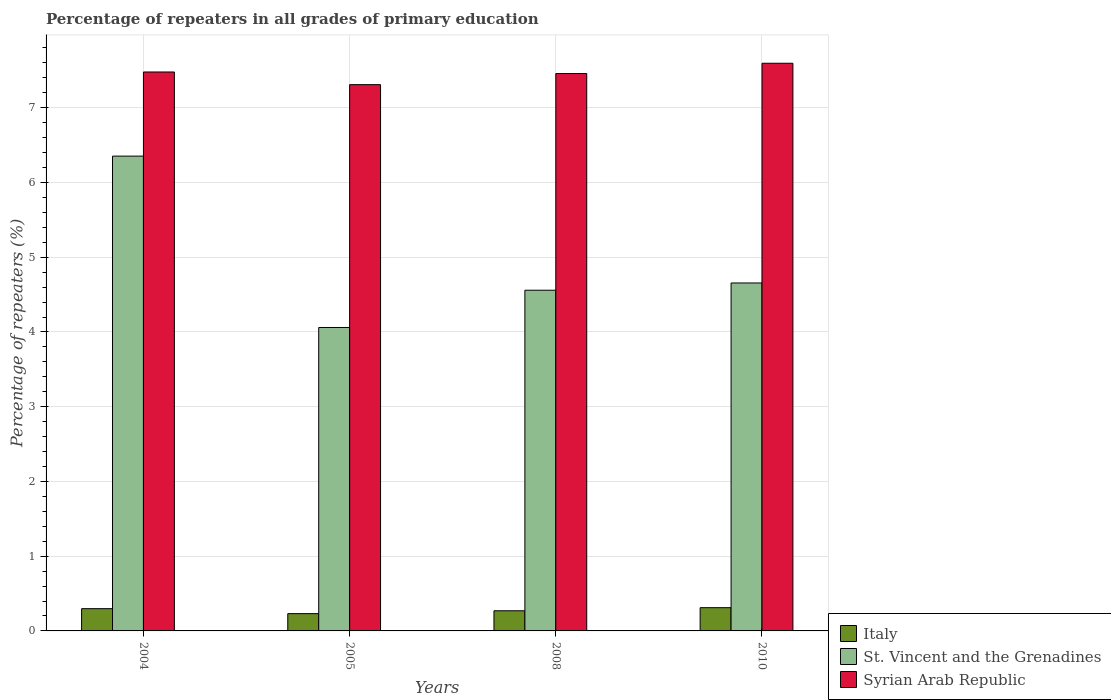How many groups of bars are there?
Offer a terse response. 4. Are the number of bars per tick equal to the number of legend labels?
Offer a terse response. Yes. Are the number of bars on each tick of the X-axis equal?
Your answer should be very brief. Yes. How many bars are there on the 2nd tick from the right?
Ensure brevity in your answer.  3. What is the label of the 3rd group of bars from the left?
Your answer should be compact. 2008. In how many cases, is the number of bars for a given year not equal to the number of legend labels?
Make the answer very short. 0. What is the percentage of repeaters in Italy in 2005?
Provide a succinct answer. 0.23. Across all years, what is the maximum percentage of repeaters in Italy?
Ensure brevity in your answer.  0.31. Across all years, what is the minimum percentage of repeaters in St. Vincent and the Grenadines?
Give a very brief answer. 4.06. What is the total percentage of repeaters in St. Vincent and the Grenadines in the graph?
Offer a very short reply. 19.63. What is the difference between the percentage of repeaters in Syrian Arab Republic in 2008 and that in 2010?
Your answer should be compact. -0.14. What is the difference between the percentage of repeaters in Italy in 2008 and the percentage of repeaters in St. Vincent and the Grenadines in 2004?
Offer a very short reply. -6.08. What is the average percentage of repeaters in Italy per year?
Offer a very short reply. 0.28. In the year 2010, what is the difference between the percentage of repeaters in Syrian Arab Republic and percentage of repeaters in St. Vincent and the Grenadines?
Give a very brief answer. 2.94. In how many years, is the percentage of repeaters in Syrian Arab Republic greater than 0.6000000000000001 %?
Ensure brevity in your answer.  4. What is the ratio of the percentage of repeaters in St. Vincent and the Grenadines in 2005 to that in 2008?
Offer a very short reply. 0.89. Is the difference between the percentage of repeaters in Syrian Arab Republic in 2004 and 2008 greater than the difference between the percentage of repeaters in St. Vincent and the Grenadines in 2004 and 2008?
Make the answer very short. No. What is the difference between the highest and the second highest percentage of repeaters in St. Vincent and the Grenadines?
Ensure brevity in your answer.  1.7. What is the difference between the highest and the lowest percentage of repeaters in Italy?
Your response must be concise. 0.08. What does the 3rd bar from the left in 2010 represents?
Your answer should be very brief. Syrian Arab Republic. What does the 2nd bar from the right in 2010 represents?
Offer a terse response. St. Vincent and the Grenadines. How many years are there in the graph?
Offer a very short reply. 4. Does the graph contain any zero values?
Provide a short and direct response. No. Does the graph contain grids?
Make the answer very short. Yes. How many legend labels are there?
Make the answer very short. 3. What is the title of the graph?
Ensure brevity in your answer.  Percentage of repeaters in all grades of primary education. Does "Central Europe" appear as one of the legend labels in the graph?
Provide a succinct answer. No. What is the label or title of the Y-axis?
Your response must be concise. Percentage of repeaters (%). What is the Percentage of repeaters (%) of Italy in 2004?
Give a very brief answer. 0.3. What is the Percentage of repeaters (%) of St. Vincent and the Grenadines in 2004?
Your answer should be very brief. 6.35. What is the Percentage of repeaters (%) in Syrian Arab Republic in 2004?
Offer a terse response. 7.48. What is the Percentage of repeaters (%) of Italy in 2005?
Provide a short and direct response. 0.23. What is the Percentage of repeaters (%) of St. Vincent and the Grenadines in 2005?
Your response must be concise. 4.06. What is the Percentage of repeaters (%) of Syrian Arab Republic in 2005?
Keep it short and to the point. 7.31. What is the Percentage of repeaters (%) of Italy in 2008?
Make the answer very short. 0.27. What is the Percentage of repeaters (%) of St. Vincent and the Grenadines in 2008?
Offer a terse response. 4.56. What is the Percentage of repeaters (%) in Syrian Arab Republic in 2008?
Offer a terse response. 7.46. What is the Percentage of repeaters (%) of Italy in 2010?
Your answer should be very brief. 0.31. What is the Percentage of repeaters (%) of St. Vincent and the Grenadines in 2010?
Ensure brevity in your answer.  4.66. What is the Percentage of repeaters (%) of Syrian Arab Republic in 2010?
Provide a short and direct response. 7.6. Across all years, what is the maximum Percentage of repeaters (%) of Italy?
Your response must be concise. 0.31. Across all years, what is the maximum Percentage of repeaters (%) of St. Vincent and the Grenadines?
Make the answer very short. 6.35. Across all years, what is the maximum Percentage of repeaters (%) in Syrian Arab Republic?
Keep it short and to the point. 7.6. Across all years, what is the minimum Percentage of repeaters (%) in Italy?
Your answer should be very brief. 0.23. Across all years, what is the minimum Percentage of repeaters (%) of St. Vincent and the Grenadines?
Your answer should be very brief. 4.06. Across all years, what is the minimum Percentage of repeaters (%) in Syrian Arab Republic?
Give a very brief answer. 7.31. What is the total Percentage of repeaters (%) in Italy in the graph?
Provide a succinct answer. 1.11. What is the total Percentage of repeaters (%) of St. Vincent and the Grenadines in the graph?
Your response must be concise. 19.63. What is the total Percentage of repeaters (%) in Syrian Arab Republic in the graph?
Make the answer very short. 29.84. What is the difference between the Percentage of repeaters (%) of Italy in 2004 and that in 2005?
Give a very brief answer. 0.07. What is the difference between the Percentage of repeaters (%) in St. Vincent and the Grenadines in 2004 and that in 2005?
Your answer should be very brief. 2.29. What is the difference between the Percentage of repeaters (%) of Syrian Arab Republic in 2004 and that in 2005?
Your answer should be compact. 0.17. What is the difference between the Percentage of repeaters (%) in Italy in 2004 and that in 2008?
Your answer should be compact. 0.03. What is the difference between the Percentage of repeaters (%) in St. Vincent and the Grenadines in 2004 and that in 2008?
Offer a terse response. 1.79. What is the difference between the Percentage of repeaters (%) of Syrian Arab Republic in 2004 and that in 2008?
Make the answer very short. 0.02. What is the difference between the Percentage of repeaters (%) of Italy in 2004 and that in 2010?
Offer a very short reply. -0.01. What is the difference between the Percentage of repeaters (%) in St. Vincent and the Grenadines in 2004 and that in 2010?
Offer a terse response. 1.7. What is the difference between the Percentage of repeaters (%) in Syrian Arab Republic in 2004 and that in 2010?
Your answer should be very brief. -0.12. What is the difference between the Percentage of repeaters (%) in Italy in 2005 and that in 2008?
Your answer should be compact. -0.04. What is the difference between the Percentage of repeaters (%) in St. Vincent and the Grenadines in 2005 and that in 2008?
Keep it short and to the point. -0.5. What is the difference between the Percentage of repeaters (%) in Syrian Arab Republic in 2005 and that in 2008?
Provide a succinct answer. -0.15. What is the difference between the Percentage of repeaters (%) in Italy in 2005 and that in 2010?
Keep it short and to the point. -0.08. What is the difference between the Percentage of repeaters (%) in St. Vincent and the Grenadines in 2005 and that in 2010?
Provide a succinct answer. -0.6. What is the difference between the Percentage of repeaters (%) of Syrian Arab Republic in 2005 and that in 2010?
Your response must be concise. -0.29. What is the difference between the Percentage of repeaters (%) of Italy in 2008 and that in 2010?
Provide a succinct answer. -0.04. What is the difference between the Percentage of repeaters (%) in St. Vincent and the Grenadines in 2008 and that in 2010?
Offer a very short reply. -0.1. What is the difference between the Percentage of repeaters (%) in Syrian Arab Republic in 2008 and that in 2010?
Keep it short and to the point. -0.14. What is the difference between the Percentage of repeaters (%) in Italy in 2004 and the Percentage of repeaters (%) in St. Vincent and the Grenadines in 2005?
Provide a short and direct response. -3.76. What is the difference between the Percentage of repeaters (%) in Italy in 2004 and the Percentage of repeaters (%) in Syrian Arab Republic in 2005?
Provide a short and direct response. -7.01. What is the difference between the Percentage of repeaters (%) of St. Vincent and the Grenadines in 2004 and the Percentage of repeaters (%) of Syrian Arab Republic in 2005?
Provide a succinct answer. -0.96. What is the difference between the Percentage of repeaters (%) of Italy in 2004 and the Percentage of repeaters (%) of St. Vincent and the Grenadines in 2008?
Make the answer very short. -4.26. What is the difference between the Percentage of repeaters (%) in Italy in 2004 and the Percentage of repeaters (%) in Syrian Arab Republic in 2008?
Your answer should be very brief. -7.16. What is the difference between the Percentage of repeaters (%) in St. Vincent and the Grenadines in 2004 and the Percentage of repeaters (%) in Syrian Arab Republic in 2008?
Provide a short and direct response. -1.1. What is the difference between the Percentage of repeaters (%) of Italy in 2004 and the Percentage of repeaters (%) of St. Vincent and the Grenadines in 2010?
Your response must be concise. -4.36. What is the difference between the Percentage of repeaters (%) in Italy in 2004 and the Percentage of repeaters (%) in Syrian Arab Republic in 2010?
Provide a succinct answer. -7.3. What is the difference between the Percentage of repeaters (%) of St. Vincent and the Grenadines in 2004 and the Percentage of repeaters (%) of Syrian Arab Republic in 2010?
Make the answer very short. -1.24. What is the difference between the Percentage of repeaters (%) in Italy in 2005 and the Percentage of repeaters (%) in St. Vincent and the Grenadines in 2008?
Give a very brief answer. -4.33. What is the difference between the Percentage of repeaters (%) of Italy in 2005 and the Percentage of repeaters (%) of Syrian Arab Republic in 2008?
Your answer should be very brief. -7.23. What is the difference between the Percentage of repeaters (%) in St. Vincent and the Grenadines in 2005 and the Percentage of repeaters (%) in Syrian Arab Republic in 2008?
Ensure brevity in your answer.  -3.4. What is the difference between the Percentage of repeaters (%) of Italy in 2005 and the Percentage of repeaters (%) of St. Vincent and the Grenadines in 2010?
Your answer should be compact. -4.42. What is the difference between the Percentage of repeaters (%) in Italy in 2005 and the Percentage of repeaters (%) in Syrian Arab Republic in 2010?
Offer a terse response. -7.36. What is the difference between the Percentage of repeaters (%) of St. Vincent and the Grenadines in 2005 and the Percentage of repeaters (%) of Syrian Arab Republic in 2010?
Your answer should be compact. -3.54. What is the difference between the Percentage of repeaters (%) in Italy in 2008 and the Percentage of repeaters (%) in St. Vincent and the Grenadines in 2010?
Provide a succinct answer. -4.39. What is the difference between the Percentage of repeaters (%) of Italy in 2008 and the Percentage of repeaters (%) of Syrian Arab Republic in 2010?
Give a very brief answer. -7.33. What is the difference between the Percentage of repeaters (%) of St. Vincent and the Grenadines in 2008 and the Percentage of repeaters (%) of Syrian Arab Republic in 2010?
Make the answer very short. -3.04. What is the average Percentage of repeaters (%) in Italy per year?
Give a very brief answer. 0.28. What is the average Percentage of repeaters (%) in St. Vincent and the Grenadines per year?
Make the answer very short. 4.91. What is the average Percentage of repeaters (%) in Syrian Arab Republic per year?
Provide a short and direct response. 7.46. In the year 2004, what is the difference between the Percentage of repeaters (%) in Italy and Percentage of repeaters (%) in St. Vincent and the Grenadines?
Your response must be concise. -6.05. In the year 2004, what is the difference between the Percentage of repeaters (%) of Italy and Percentage of repeaters (%) of Syrian Arab Republic?
Your answer should be compact. -7.18. In the year 2004, what is the difference between the Percentage of repeaters (%) of St. Vincent and the Grenadines and Percentage of repeaters (%) of Syrian Arab Republic?
Offer a terse response. -1.13. In the year 2005, what is the difference between the Percentage of repeaters (%) in Italy and Percentage of repeaters (%) in St. Vincent and the Grenadines?
Make the answer very short. -3.83. In the year 2005, what is the difference between the Percentage of repeaters (%) in Italy and Percentage of repeaters (%) in Syrian Arab Republic?
Your answer should be compact. -7.08. In the year 2005, what is the difference between the Percentage of repeaters (%) in St. Vincent and the Grenadines and Percentage of repeaters (%) in Syrian Arab Republic?
Your answer should be compact. -3.25. In the year 2008, what is the difference between the Percentage of repeaters (%) in Italy and Percentage of repeaters (%) in St. Vincent and the Grenadines?
Provide a succinct answer. -4.29. In the year 2008, what is the difference between the Percentage of repeaters (%) of Italy and Percentage of repeaters (%) of Syrian Arab Republic?
Your response must be concise. -7.19. In the year 2008, what is the difference between the Percentage of repeaters (%) of St. Vincent and the Grenadines and Percentage of repeaters (%) of Syrian Arab Republic?
Provide a succinct answer. -2.9. In the year 2010, what is the difference between the Percentage of repeaters (%) of Italy and Percentage of repeaters (%) of St. Vincent and the Grenadines?
Offer a terse response. -4.34. In the year 2010, what is the difference between the Percentage of repeaters (%) in Italy and Percentage of repeaters (%) in Syrian Arab Republic?
Give a very brief answer. -7.28. In the year 2010, what is the difference between the Percentage of repeaters (%) in St. Vincent and the Grenadines and Percentage of repeaters (%) in Syrian Arab Republic?
Your answer should be compact. -2.94. What is the ratio of the Percentage of repeaters (%) of Italy in 2004 to that in 2005?
Offer a terse response. 1.29. What is the ratio of the Percentage of repeaters (%) of St. Vincent and the Grenadines in 2004 to that in 2005?
Make the answer very short. 1.56. What is the ratio of the Percentage of repeaters (%) in Syrian Arab Republic in 2004 to that in 2005?
Provide a short and direct response. 1.02. What is the ratio of the Percentage of repeaters (%) in Italy in 2004 to that in 2008?
Offer a terse response. 1.1. What is the ratio of the Percentage of repeaters (%) in St. Vincent and the Grenadines in 2004 to that in 2008?
Give a very brief answer. 1.39. What is the ratio of the Percentage of repeaters (%) in Syrian Arab Republic in 2004 to that in 2008?
Your answer should be very brief. 1. What is the ratio of the Percentage of repeaters (%) of Italy in 2004 to that in 2010?
Give a very brief answer. 0.96. What is the ratio of the Percentage of repeaters (%) in St. Vincent and the Grenadines in 2004 to that in 2010?
Offer a very short reply. 1.36. What is the ratio of the Percentage of repeaters (%) in Syrian Arab Republic in 2004 to that in 2010?
Offer a terse response. 0.98. What is the ratio of the Percentage of repeaters (%) in Italy in 2005 to that in 2008?
Provide a succinct answer. 0.86. What is the ratio of the Percentage of repeaters (%) of St. Vincent and the Grenadines in 2005 to that in 2008?
Your response must be concise. 0.89. What is the ratio of the Percentage of repeaters (%) of Syrian Arab Republic in 2005 to that in 2008?
Your response must be concise. 0.98. What is the ratio of the Percentage of repeaters (%) of Italy in 2005 to that in 2010?
Provide a succinct answer. 0.74. What is the ratio of the Percentage of repeaters (%) of St. Vincent and the Grenadines in 2005 to that in 2010?
Provide a short and direct response. 0.87. What is the ratio of the Percentage of repeaters (%) in Syrian Arab Republic in 2005 to that in 2010?
Ensure brevity in your answer.  0.96. What is the ratio of the Percentage of repeaters (%) in Italy in 2008 to that in 2010?
Make the answer very short. 0.87. What is the ratio of the Percentage of repeaters (%) of St. Vincent and the Grenadines in 2008 to that in 2010?
Provide a short and direct response. 0.98. What is the ratio of the Percentage of repeaters (%) in Syrian Arab Republic in 2008 to that in 2010?
Give a very brief answer. 0.98. What is the difference between the highest and the second highest Percentage of repeaters (%) in Italy?
Offer a terse response. 0.01. What is the difference between the highest and the second highest Percentage of repeaters (%) in St. Vincent and the Grenadines?
Your answer should be compact. 1.7. What is the difference between the highest and the second highest Percentage of repeaters (%) of Syrian Arab Republic?
Provide a succinct answer. 0.12. What is the difference between the highest and the lowest Percentage of repeaters (%) in Italy?
Offer a very short reply. 0.08. What is the difference between the highest and the lowest Percentage of repeaters (%) in St. Vincent and the Grenadines?
Your answer should be very brief. 2.29. What is the difference between the highest and the lowest Percentage of repeaters (%) of Syrian Arab Republic?
Offer a terse response. 0.29. 